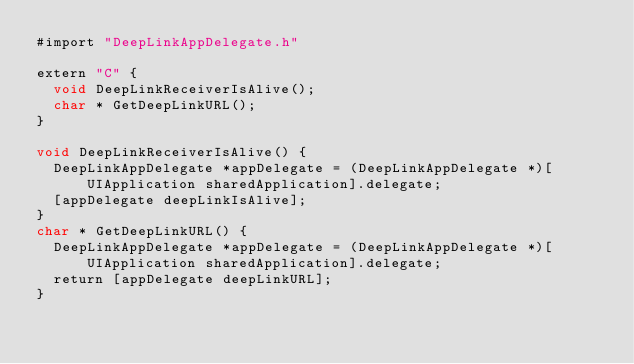<code> <loc_0><loc_0><loc_500><loc_500><_ObjectiveC_>#import "DeepLinkAppDelegate.h"

extern "C" {
	void DeepLinkReceiverIsAlive();
	char * GetDeepLinkURL();
}

void DeepLinkReceiverIsAlive() {
	DeepLinkAppDelegate *appDelegate = (DeepLinkAppDelegate *)[UIApplication sharedApplication].delegate;
	[appDelegate deepLinkIsAlive];
}
char * GetDeepLinkURL() {
	DeepLinkAppDelegate *appDelegate = (DeepLinkAppDelegate *)[UIApplication sharedApplication].delegate;
	return [appDelegate deepLinkURL];
}</code> 